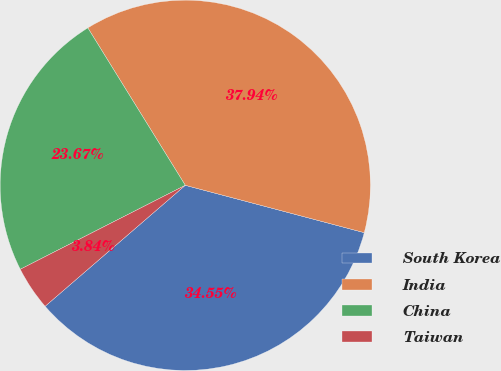Convert chart. <chart><loc_0><loc_0><loc_500><loc_500><pie_chart><fcel>South Korea<fcel>India<fcel>China<fcel>Taiwan<nl><fcel>34.55%<fcel>37.94%<fcel>23.67%<fcel>3.84%<nl></chart> 